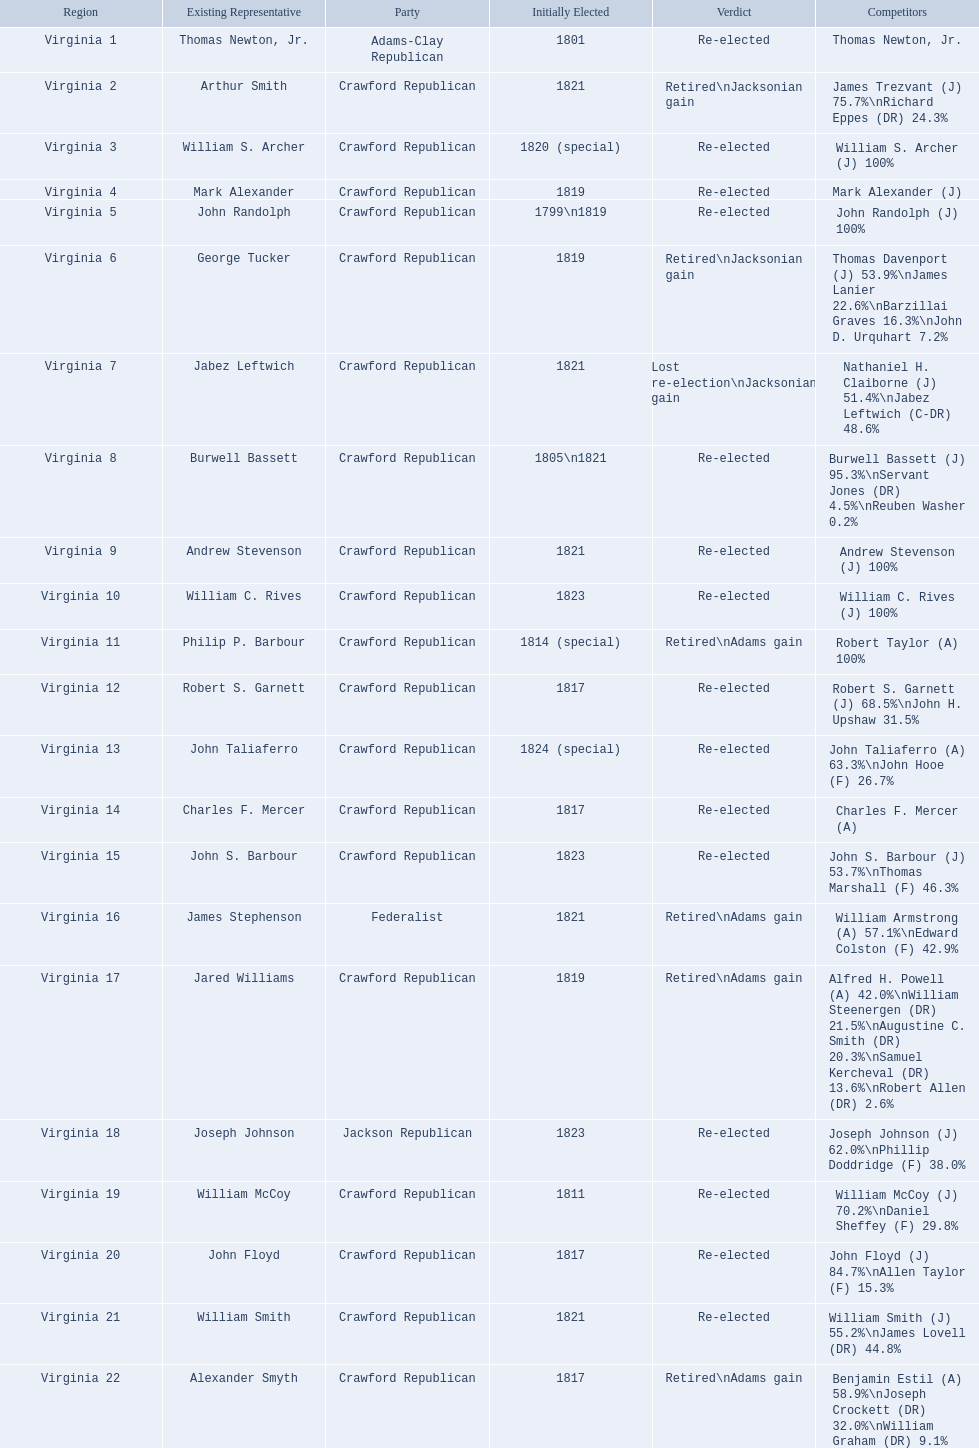Which incumbents belonged to the crawford republican party? Arthur Smith, William S. Archer, Mark Alexander, John Randolph, George Tucker, Jabez Leftwich, Burwell Bassett, Andrew Stevenson, William C. Rives, Philip P. Barbour, Robert S. Garnett, John Taliaferro, Charles F. Mercer, John S. Barbour, Jared Williams, William McCoy, John Floyd, William Smith, Alexander Smyth. Which of these incumbents were first elected in 1821? Arthur Smith, Jabez Leftwich, Andrew Stevenson, William Smith. Which of these incumbents have a last name of smith? Arthur Smith, William Smith. Which of these two were not re-elected? Arthur Smith. 